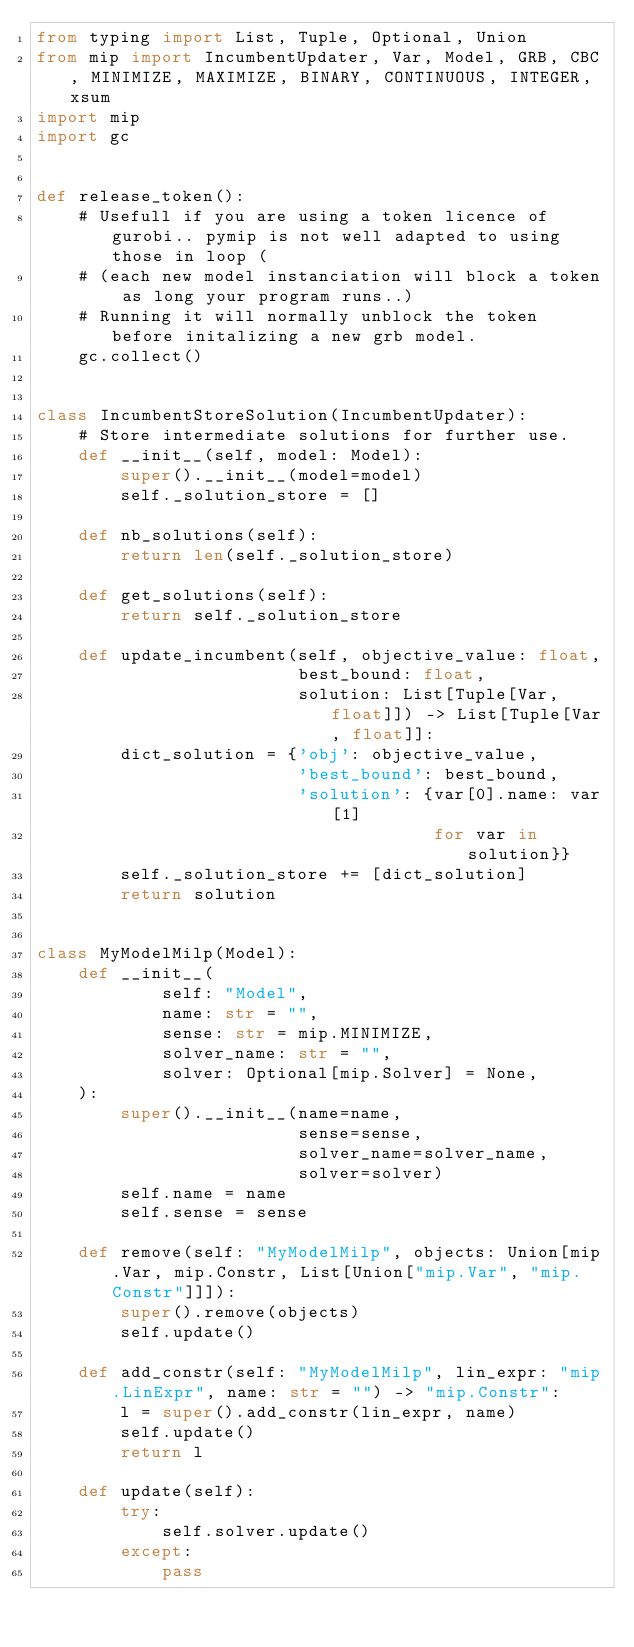Convert code to text. <code><loc_0><loc_0><loc_500><loc_500><_Python_>from typing import List, Tuple, Optional, Union
from mip import IncumbentUpdater, Var, Model, GRB, CBC, MINIMIZE, MAXIMIZE, BINARY, CONTINUOUS, INTEGER, xsum
import mip
import gc


def release_token():
    # Usefull if you are using a token licence of gurobi.. pymip is not well adapted to using those in loop (
    # (each new model instanciation will block a token as long your program runs..)
    # Running it will normally unblock the token before initalizing a new grb model.
    gc.collect()


class IncumbentStoreSolution(IncumbentUpdater):
    # Store intermediate solutions for further use.
    def __init__(self, model: Model):
        super().__init__(model=model)
        self._solution_store = []

    def nb_solutions(self):
        return len(self._solution_store)

    def get_solutions(self):
        return self._solution_store

    def update_incumbent(self, objective_value: float,
                         best_bound: float,
                         solution: List[Tuple[Var, float]]) -> List[Tuple[Var, float]]:
        dict_solution = {'obj': objective_value,
                         'best_bound': best_bound,
                         'solution': {var[0].name: var[1]
                                      for var in solution}}
        self._solution_store += [dict_solution]
        return solution


class MyModelMilp(Model):
    def __init__(
            self: "Model",
            name: str = "",
            sense: str = mip.MINIMIZE,
            solver_name: str = "",
            solver: Optional[mip.Solver] = None,
    ):
        super().__init__(name=name,
                         sense=sense,
                         solver_name=solver_name,
                         solver=solver)
        self.name = name
        self.sense = sense

    def remove(self: "MyModelMilp", objects: Union[mip.Var, mip.Constr, List[Union["mip.Var", "mip.Constr"]]]):
        super().remove(objects)
        self.update()

    def add_constr(self: "MyModelMilp", lin_expr: "mip.LinExpr", name: str = "") -> "mip.Constr":
        l = super().add_constr(lin_expr, name)
        self.update()
        return l

    def update(self):
        try:
            self.solver.update()
        except:
            pass
</code> 